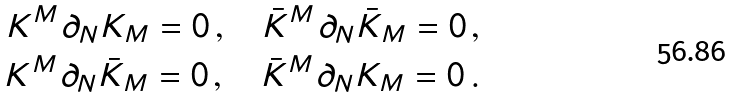<formula> <loc_0><loc_0><loc_500><loc_500>K ^ { M } \partial _ { N } K _ { M } = 0 \, , \quad \bar { K } ^ { M } \partial _ { N } \bar { K } _ { M } = 0 \, , \\ K ^ { M } \partial _ { N } \bar { K } _ { M } = 0 \, , \quad \bar { K } ^ { M } \partial _ { N } K _ { M } = 0 \, .</formula> 